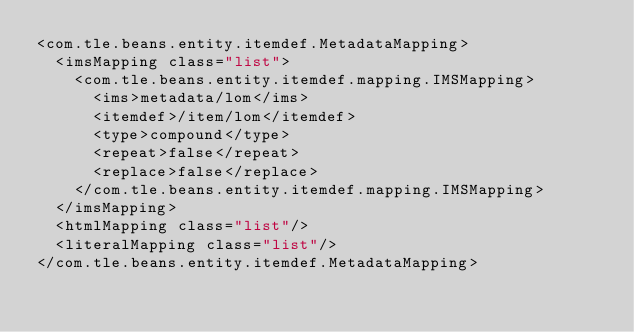<code> <loc_0><loc_0><loc_500><loc_500><_XML_><com.tle.beans.entity.itemdef.MetadataMapping>
  <imsMapping class="list">
    <com.tle.beans.entity.itemdef.mapping.IMSMapping>
      <ims>metadata/lom</ims>
      <itemdef>/item/lom</itemdef>
      <type>compound</type>
      <repeat>false</repeat>
      <replace>false</replace>
    </com.tle.beans.entity.itemdef.mapping.IMSMapping>
  </imsMapping>
  <htmlMapping class="list"/>
  <literalMapping class="list"/>
</com.tle.beans.entity.itemdef.MetadataMapping></code> 